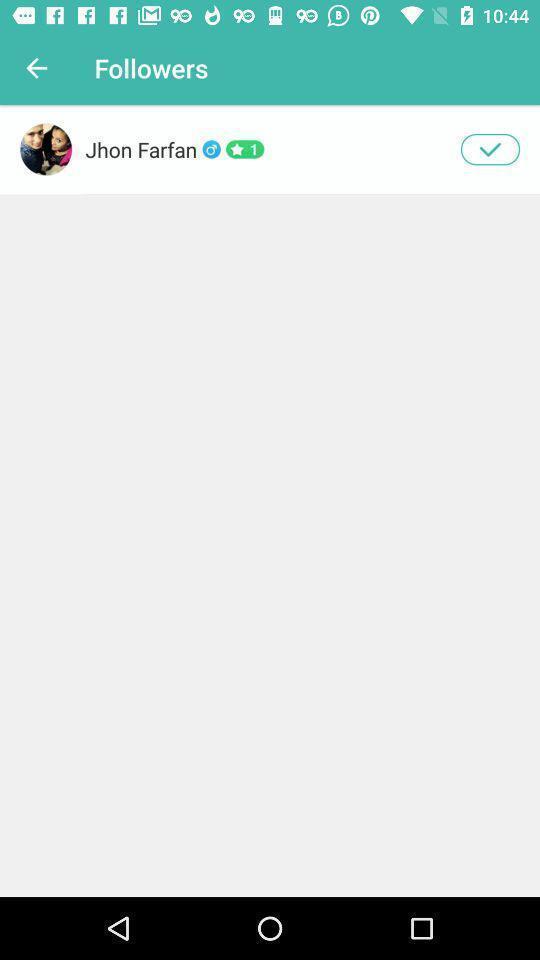Give me a narrative description of this picture. Page showing followers on a social app. 